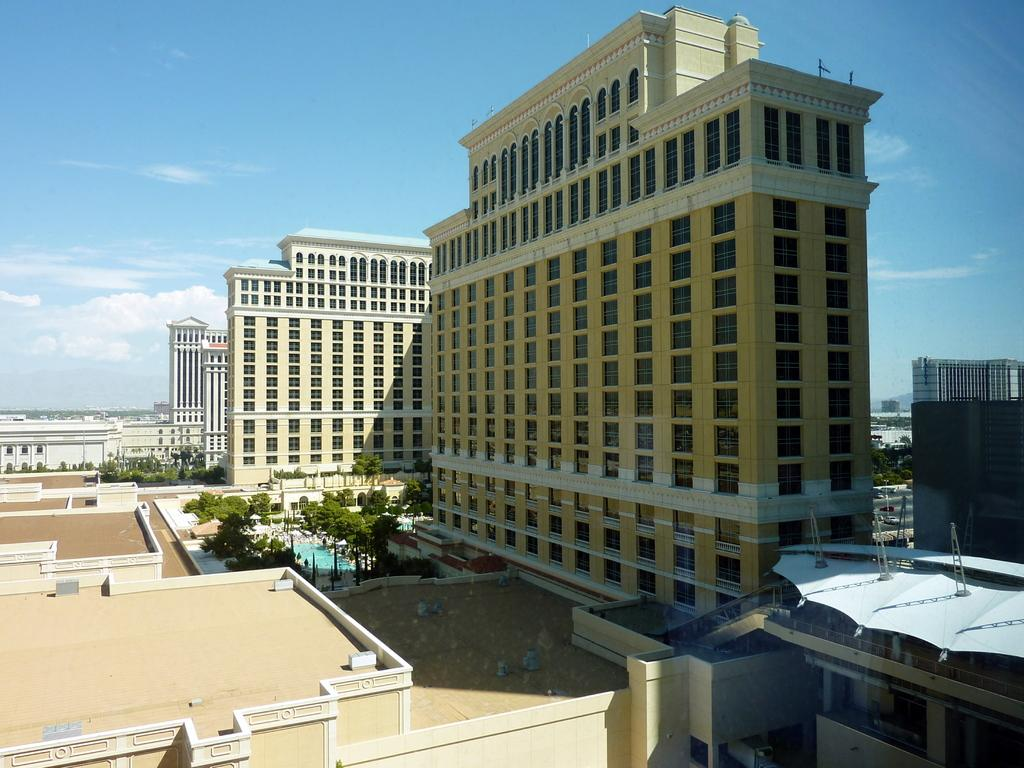What type of structures can be seen in the image? There are buildings in the image. What is located in the center of the image? There is a swimming pool in the center of the image. What surrounds the swimming pool? There are trees around the swimming pool. What is visible at the top of the image? The sky is visible at the top of the image. What is the reaction of the trees to the afternoon sun in the image? There is no indication of a reaction by the trees in the image, and the time of day is not specified. 